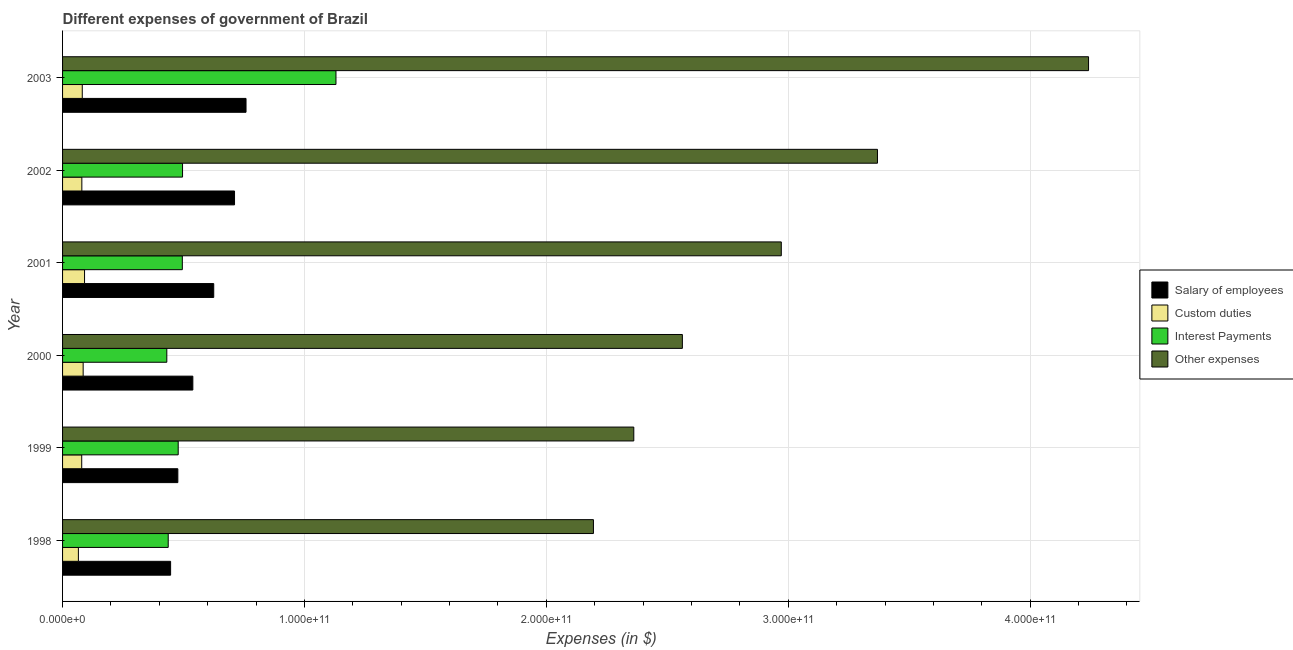Are the number of bars per tick equal to the number of legend labels?
Make the answer very short. Yes. Are the number of bars on each tick of the Y-axis equal?
Make the answer very short. Yes. What is the label of the 4th group of bars from the top?
Your answer should be compact. 2000. What is the amount spent on custom duties in 2001?
Your answer should be very brief. 9.09e+09. Across all years, what is the maximum amount spent on other expenses?
Provide a short and direct response. 4.24e+11. Across all years, what is the minimum amount spent on other expenses?
Offer a terse response. 2.19e+11. In which year was the amount spent on interest payments maximum?
Give a very brief answer. 2003. What is the total amount spent on interest payments in the graph?
Your response must be concise. 3.47e+11. What is the difference between the amount spent on interest payments in 2000 and that in 2003?
Ensure brevity in your answer.  -6.99e+1. What is the difference between the amount spent on custom duties in 1999 and the amount spent on interest payments in 1998?
Give a very brief answer. -3.58e+1. What is the average amount spent on custom duties per year?
Your answer should be very brief. 8.03e+09. In the year 1999, what is the difference between the amount spent on custom duties and amount spent on interest payments?
Make the answer very short. -3.99e+1. What is the ratio of the amount spent on salary of employees in 2001 to that in 2002?
Provide a short and direct response. 0.88. Is the difference between the amount spent on interest payments in 1999 and 2003 greater than the difference between the amount spent on salary of employees in 1999 and 2003?
Your answer should be very brief. No. What is the difference between the highest and the second highest amount spent on other expenses?
Offer a very short reply. 8.73e+1. What is the difference between the highest and the lowest amount spent on other expenses?
Offer a terse response. 2.05e+11. In how many years, is the amount spent on custom duties greater than the average amount spent on custom duties taken over all years?
Your answer should be very brief. 3. Is it the case that in every year, the sum of the amount spent on interest payments and amount spent on salary of employees is greater than the sum of amount spent on custom duties and amount spent on other expenses?
Offer a very short reply. No. What does the 2nd bar from the top in 2003 represents?
Give a very brief answer. Interest Payments. What does the 4th bar from the bottom in 2001 represents?
Ensure brevity in your answer.  Other expenses. Is it the case that in every year, the sum of the amount spent on salary of employees and amount spent on custom duties is greater than the amount spent on interest payments?
Offer a very short reply. No. How many bars are there?
Your answer should be compact. 24. Are all the bars in the graph horizontal?
Make the answer very short. Yes. What is the difference between two consecutive major ticks on the X-axis?
Ensure brevity in your answer.  1.00e+11. Are the values on the major ticks of X-axis written in scientific E-notation?
Ensure brevity in your answer.  Yes. Does the graph contain grids?
Offer a terse response. Yes. What is the title of the graph?
Give a very brief answer. Different expenses of government of Brazil. What is the label or title of the X-axis?
Your response must be concise. Expenses (in $). What is the label or title of the Y-axis?
Ensure brevity in your answer.  Year. What is the Expenses (in $) in Salary of employees in 1998?
Your answer should be very brief. 4.47e+1. What is the Expenses (in $) in Custom duties in 1998?
Keep it short and to the point. 6.54e+09. What is the Expenses (in $) of Interest Payments in 1998?
Offer a very short reply. 4.37e+1. What is the Expenses (in $) in Other expenses in 1998?
Provide a succinct answer. 2.19e+11. What is the Expenses (in $) of Salary of employees in 1999?
Provide a succinct answer. 4.77e+1. What is the Expenses (in $) in Custom duties in 1999?
Ensure brevity in your answer.  7.92e+09. What is the Expenses (in $) of Interest Payments in 1999?
Ensure brevity in your answer.  4.78e+1. What is the Expenses (in $) of Other expenses in 1999?
Offer a very short reply. 2.36e+11. What is the Expenses (in $) in Salary of employees in 2000?
Provide a short and direct response. 5.39e+1. What is the Expenses (in $) in Custom duties in 2000?
Provide a succinct answer. 8.51e+09. What is the Expenses (in $) in Interest Payments in 2000?
Offer a terse response. 4.31e+1. What is the Expenses (in $) in Other expenses in 2000?
Keep it short and to the point. 2.56e+11. What is the Expenses (in $) in Salary of employees in 2001?
Make the answer very short. 6.25e+1. What is the Expenses (in $) of Custom duties in 2001?
Provide a short and direct response. 9.09e+09. What is the Expenses (in $) in Interest Payments in 2001?
Offer a very short reply. 4.95e+1. What is the Expenses (in $) in Other expenses in 2001?
Offer a terse response. 2.97e+11. What is the Expenses (in $) of Salary of employees in 2002?
Your answer should be compact. 7.11e+1. What is the Expenses (in $) in Custom duties in 2002?
Make the answer very short. 7.97e+09. What is the Expenses (in $) in Interest Payments in 2002?
Make the answer very short. 4.96e+1. What is the Expenses (in $) of Other expenses in 2002?
Your response must be concise. 3.37e+11. What is the Expenses (in $) in Salary of employees in 2003?
Provide a succinct answer. 7.58e+1. What is the Expenses (in $) in Custom duties in 2003?
Your answer should be very brief. 8.14e+09. What is the Expenses (in $) in Interest Payments in 2003?
Offer a very short reply. 1.13e+11. What is the Expenses (in $) of Other expenses in 2003?
Your response must be concise. 4.24e+11. Across all years, what is the maximum Expenses (in $) of Salary of employees?
Provide a short and direct response. 7.58e+1. Across all years, what is the maximum Expenses (in $) of Custom duties?
Make the answer very short. 9.09e+09. Across all years, what is the maximum Expenses (in $) of Interest Payments?
Ensure brevity in your answer.  1.13e+11. Across all years, what is the maximum Expenses (in $) of Other expenses?
Offer a very short reply. 4.24e+11. Across all years, what is the minimum Expenses (in $) in Salary of employees?
Make the answer very short. 4.47e+1. Across all years, what is the minimum Expenses (in $) in Custom duties?
Offer a very short reply. 6.54e+09. Across all years, what is the minimum Expenses (in $) of Interest Payments?
Ensure brevity in your answer.  4.31e+1. Across all years, what is the minimum Expenses (in $) in Other expenses?
Offer a very short reply. 2.19e+11. What is the total Expenses (in $) in Salary of employees in the graph?
Your response must be concise. 3.56e+11. What is the total Expenses (in $) in Custom duties in the graph?
Provide a succinct answer. 4.82e+1. What is the total Expenses (in $) of Interest Payments in the graph?
Provide a short and direct response. 3.47e+11. What is the total Expenses (in $) of Other expenses in the graph?
Your answer should be compact. 1.77e+12. What is the difference between the Expenses (in $) in Salary of employees in 1998 and that in 1999?
Offer a very short reply. -2.99e+09. What is the difference between the Expenses (in $) of Custom duties in 1998 and that in 1999?
Offer a terse response. -1.37e+09. What is the difference between the Expenses (in $) of Interest Payments in 1998 and that in 1999?
Ensure brevity in your answer.  -4.13e+09. What is the difference between the Expenses (in $) in Other expenses in 1998 and that in 1999?
Keep it short and to the point. -1.67e+1. What is the difference between the Expenses (in $) in Salary of employees in 1998 and that in 2000?
Make the answer very short. -9.19e+09. What is the difference between the Expenses (in $) of Custom duties in 1998 and that in 2000?
Your answer should be compact. -1.97e+09. What is the difference between the Expenses (in $) of Interest Payments in 1998 and that in 2000?
Your answer should be very brief. 5.82e+08. What is the difference between the Expenses (in $) of Other expenses in 1998 and that in 2000?
Ensure brevity in your answer.  -3.68e+1. What is the difference between the Expenses (in $) in Salary of employees in 1998 and that in 2001?
Provide a succinct answer. -1.78e+1. What is the difference between the Expenses (in $) in Custom duties in 1998 and that in 2001?
Keep it short and to the point. -2.54e+09. What is the difference between the Expenses (in $) of Interest Payments in 1998 and that in 2001?
Offer a terse response. -5.83e+09. What is the difference between the Expenses (in $) of Other expenses in 1998 and that in 2001?
Your answer should be compact. -7.77e+1. What is the difference between the Expenses (in $) in Salary of employees in 1998 and that in 2002?
Give a very brief answer. -2.64e+1. What is the difference between the Expenses (in $) of Custom duties in 1998 and that in 2002?
Give a very brief answer. -1.43e+09. What is the difference between the Expenses (in $) of Interest Payments in 1998 and that in 2002?
Offer a terse response. -5.92e+09. What is the difference between the Expenses (in $) of Other expenses in 1998 and that in 2002?
Make the answer very short. -1.17e+11. What is the difference between the Expenses (in $) of Salary of employees in 1998 and that in 2003?
Offer a very short reply. -3.12e+1. What is the difference between the Expenses (in $) in Custom duties in 1998 and that in 2003?
Ensure brevity in your answer.  -1.60e+09. What is the difference between the Expenses (in $) in Interest Payments in 1998 and that in 2003?
Offer a very short reply. -6.93e+1. What is the difference between the Expenses (in $) of Other expenses in 1998 and that in 2003?
Your response must be concise. -2.05e+11. What is the difference between the Expenses (in $) in Salary of employees in 1999 and that in 2000?
Provide a short and direct response. -6.20e+09. What is the difference between the Expenses (in $) in Custom duties in 1999 and that in 2000?
Give a very brief answer. -5.94e+08. What is the difference between the Expenses (in $) of Interest Payments in 1999 and that in 2000?
Keep it short and to the point. 4.71e+09. What is the difference between the Expenses (in $) in Other expenses in 1999 and that in 2000?
Ensure brevity in your answer.  -2.01e+1. What is the difference between the Expenses (in $) of Salary of employees in 1999 and that in 2001?
Provide a short and direct response. -1.48e+1. What is the difference between the Expenses (in $) of Custom duties in 1999 and that in 2001?
Make the answer very short. -1.17e+09. What is the difference between the Expenses (in $) of Interest Payments in 1999 and that in 2001?
Your answer should be very brief. -1.71e+09. What is the difference between the Expenses (in $) in Other expenses in 1999 and that in 2001?
Offer a very short reply. -6.10e+1. What is the difference between the Expenses (in $) in Salary of employees in 1999 and that in 2002?
Your answer should be compact. -2.34e+1. What is the difference between the Expenses (in $) in Custom duties in 1999 and that in 2002?
Offer a very short reply. -5.38e+07. What is the difference between the Expenses (in $) in Interest Payments in 1999 and that in 2002?
Make the answer very short. -1.80e+09. What is the difference between the Expenses (in $) of Other expenses in 1999 and that in 2002?
Make the answer very short. -1.01e+11. What is the difference between the Expenses (in $) in Salary of employees in 1999 and that in 2003?
Your answer should be very brief. -2.82e+1. What is the difference between the Expenses (in $) of Custom duties in 1999 and that in 2003?
Your response must be concise. -2.26e+08. What is the difference between the Expenses (in $) of Interest Payments in 1999 and that in 2003?
Your answer should be very brief. -6.52e+1. What is the difference between the Expenses (in $) in Other expenses in 1999 and that in 2003?
Provide a succinct answer. -1.88e+11. What is the difference between the Expenses (in $) of Salary of employees in 2000 and that in 2001?
Provide a succinct answer. -8.64e+09. What is the difference between the Expenses (in $) in Custom duties in 2000 and that in 2001?
Keep it short and to the point. -5.77e+08. What is the difference between the Expenses (in $) in Interest Payments in 2000 and that in 2001?
Give a very brief answer. -6.41e+09. What is the difference between the Expenses (in $) of Other expenses in 2000 and that in 2001?
Your answer should be compact. -4.09e+1. What is the difference between the Expenses (in $) in Salary of employees in 2000 and that in 2002?
Make the answer very short. -1.72e+1. What is the difference between the Expenses (in $) in Custom duties in 2000 and that in 2002?
Provide a short and direct response. 5.40e+08. What is the difference between the Expenses (in $) of Interest Payments in 2000 and that in 2002?
Your answer should be compact. -6.51e+09. What is the difference between the Expenses (in $) in Other expenses in 2000 and that in 2002?
Offer a terse response. -8.06e+1. What is the difference between the Expenses (in $) of Salary of employees in 2000 and that in 2003?
Your answer should be compact. -2.20e+1. What is the difference between the Expenses (in $) in Custom duties in 2000 and that in 2003?
Keep it short and to the point. 3.68e+08. What is the difference between the Expenses (in $) of Interest Payments in 2000 and that in 2003?
Provide a succinct answer. -6.99e+1. What is the difference between the Expenses (in $) of Other expenses in 2000 and that in 2003?
Provide a short and direct response. -1.68e+11. What is the difference between the Expenses (in $) of Salary of employees in 2001 and that in 2002?
Offer a terse response. -8.60e+09. What is the difference between the Expenses (in $) of Custom duties in 2001 and that in 2002?
Provide a succinct answer. 1.12e+09. What is the difference between the Expenses (in $) of Interest Payments in 2001 and that in 2002?
Give a very brief answer. -9.06e+07. What is the difference between the Expenses (in $) of Other expenses in 2001 and that in 2002?
Give a very brief answer. -3.98e+1. What is the difference between the Expenses (in $) of Salary of employees in 2001 and that in 2003?
Offer a terse response. -1.33e+1. What is the difference between the Expenses (in $) in Custom duties in 2001 and that in 2003?
Provide a short and direct response. 9.45e+08. What is the difference between the Expenses (in $) of Interest Payments in 2001 and that in 2003?
Keep it short and to the point. -6.35e+1. What is the difference between the Expenses (in $) of Other expenses in 2001 and that in 2003?
Your answer should be compact. -1.27e+11. What is the difference between the Expenses (in $) in Salary of employees in 2002 and that in 2003?
Keep it short and to the point. -4.75e+09. What is the difference between the Expenses (in $) of Custom duties in 2002 and that in 2003?
Ensure brevity in your answer.  -1.72e+08. What is the difference between the Expenses (in $) of Interest Payments in 2002 and that in 2003?
Your answer should be compact. -6.34e+1. What is the difference between the Expenses (in $) of Other expenses in 2002 and that in 2003?
Provide a succinct answer. -8.73e+1. What is the difference between the Expenses (in $) in Salary of employees in 1998 and the Expenses (in $) in Custom duties in 1999?
Ensure brevity in your answer.  3.67e+1. What is the difference between the Expenses (in $) of Salary of employees in 1998 and the Expenses (in $) of Interest Payments in 1999?
Make the answer very short. -3.14e+09. What is the difference between the Expenses (in $) of Salary of employees in 1998 and the Expenses (in $) of Other expenses in 1999?
Ensure brevity in your answer.  -1.91e+11. What is the difference between the Expenses (in $) in Custom duties in 1998 and the Expenses (in $) in Interest Payments in 1999?
Ensure brevity in your answer.  -4.13e+1. What is the difference between the Expenses (in $) of Custom duties in 1998 and the Expenses (in $) of Other expenses in 1999?
Give a very brief answer. -2.30e+11. What is the difference between the Expenses (in $) in Interest Payments in 1998 and the Expenses (in $) in Other expenses in 1999?
Make the answer very short. -1.92e+11. What is the difference between the Expenses (in $) in Salary of employees in 1998 and the Expenses (in $) in Custom duties in 2000?
Make the answer very short. 3.62e+1. What is the difference between the Expenses (in $) of Salary of employees in 1998 and the Expenses (in $) of Interest Payments in 2000?
Ensure brevity in your answer.  1.57e+09. What is the difference between the Expenses (in $) in Salary of employees in 1998 and the Expenses (in $) in Other expenses in 2000?
Your answer should be very brief. -2.12e+11. What is the difference between the Expenses (in $) of Custom duties in 1998 and the Expenses (in $) of Interest Payments in 2000?
Offer a very short reply. -3.65e+1. What is the difference between the Expenses (in $) of Custom duties in 1998 and the Expenses (in $) of Other expenses in 2000?
Offer a very short reply. -2.50e+11. What is the difference between the Expenses (in $) of Interest Payments in 1998 and the Expenses (in $) of Other expenses in 2000?
Your answer should be very brief. -2.13e+11. What is the difference between the Expenses (in $) in Salary of employees in 1998 and the Expenses (in $) in Custom duties in 2001?
Make the answer very short. 3.56e+1. What is the difference between the Expenses (in $) of Salary of employees in 1998 and the Expenses (in $) of Interest Payments in 2001?
Your answer should be compact. -4.84e+09. What is the difference between the Expenses (in $) in Salary of employees in 1998 and the Expenses (in $) in Other expenses in 2001?
Your answer should be very brief. -2.52e+11. What is the difference between the Expenses (in $) in Custom duties in 1998 and the Expenses (in $) in Interest Payments in 2001?
Offer a very short reply. -4.30e+1. What is the difference between the Expenses (in $) in Custom duties in 1998 and the Expenses (in $) in Other expenses in 2001?
Offer a very short reply. -2.91e+11. What is the difference between the Expenses (in $) in Interest Payments in 1998 and the Expenses (in $) in Other expenses in 2001?
Offer a terse response. -2.53e+11. What is the difference between the Expenses (in $) of Salary of employees in 1998 and the Expenses (in $) of Custom duties in 2002?
Your answer should be very brief. 3.67e+1. What is the difference between the Expenses (in $) in Salary of employees in 1998 and the Expenses (in $) in Interest Payments in 2002?
Offer a very short reply. -4.93e+09. What is the difference between the Expenses (in $) in Salary of employees in 1998 and the Expenses (in $) in Other expenses in 2002?
Ensure brevity in your answer.  -2.92e+11. What is the difference between the Expenses (in $) of Custom duties in 1998 and the Expenses (in $) of Interest Payments in 2002?
Your response must be concise. -4.31e+1. What is the difference between the Expenses (in $) of Custom duties in 1998 and the Expenses (in $) of Other expenses in 2002?
Offer a terse response. -3.30e+11. What is the difference between the Expenses (in $) of Interest Payments in 1998 and the Expenses (in $) of Other expenses in 2002?
Offer a terse response. -2.93e+11. What is the difference between the Expenses (in $) of Salary of employees in 1998 and the Expenses (in $) of Custom duties in 2003?
Offer a terse response. 3.65e+1. What is the difference between the Expenses (in $) of Salary of employees in 1998 and the Expenses (in $) of Interest Payments in 2003?
Your answer should be very brief. -6.84e+1. What is the difference between the Expenses (in $) of Salary of employees in 1998 and the Expenses (in $) of Other expenses in 2003?
Your response must be concise. -3.79e+11. What is the difference between the Expenses (in $) of Custom duties in 1998 and the Expenses (in $) of Interest Payments in 2003?
Make the answer very short. -1.06e+11. What is the difference between the Expenses (in $) of Custom duties in 1998 and the Expenses (in $) of Other expenses in 2003?
Your answer should be compact. -4.18e+11. What is the difference between the Expenses (in $) in Interest Payments in 1998 and the Expenses (in $) in Other expenses in 2003?
Offer a terse response. -3.80e+11. What is the difference between the Expenses (in $) of Salary of employees in 1999 and the Expenses (in $) of Custom duties in 2000?
Make the answer very short. 3.91e+1. What is the difference between the Expenses (in $) of Salary of employees in 1999 and the Expenses (in $) of Interest Payments in 2000?
Offer a terse response. 4.56e+09. What is the difference between the Expenses (in $) in Salary of employees in 1999 and the Expenses (in $) in Other expenses in 2000?
Give a very brief answer. -2.09e+11. What is the difference between the Expenses (in $) in Custom duties in 1999 and the Expenses (in $) in Interest Payments in 2000?
Your answer should be very brief. -3.52e+1. What is the difference between the Expenses (in $) in Custom duties in 1999 and the Expenses (in $) in Other expenses in 2000?
Make the answer very short. -2.48e+11. What is the difference between the Expenses (in $) of Interest Payments in 1999 and the Expenses (in $) of Other expenses in 2000?
Ensure brevity in your answer.  -2.08e+11. What is the difference between the Expenses (in $) in Salary of employees in 1999 and the Expenses (in $) in Custom duties in 2001?
Your answer should be compact. 3.86e+1. What is the difference between the Expenses (in $) of Salary of employees in 1999 and the Expenses (in $) of Interest Payments in 2001?
Offer a very short reply. -1.85e+09. What is the difference between the Expenses (in $) in Salary of employees in 1999 and the Expenses (in $) in Other expenses in 2001?
Give a very brief answer. -2.49e+11. What is the difference between the Expenses (in $) of Custom duties in 1999 and the Expenses (in $) of Interest Payments in 2001?
Offer a very short reply. -4.16e+1. What is the difference between the Expenses (in $) in Custom duties in 1999 and the Expenses (in $) in Other expenses in 2001?
Give a very brief answer. -2.89e+11. What is the difference between the Expenses (in $) in Interest Payments in 1999 and the Expenses (in $) in Other expenses in 2001?
Provide a succinct answer. -2.49e+11. What is the difference between the Expenses (in $) in Salary of employees in 1999 and the Expenses (in $) in Custom duties in 2002?
Keep it short and to the point. 3.97e+1. What is the difference between the Expenses (in $) of Salary of employees in 1999 and the Expenses (in $) of Interest Payments in 2002?
Your response must be concise. -1.94e+09. What is the difference between the Expenses (in $) in Salary of employees in 1999 and the Expenses (in $) in Other expenses in 2002?
Your response must be concise. -2.89e+11. What is the difference between the Expenses (in $) in Custom duties in 1999 and the Expenses (in $) in Interest Payments in 2002?
Make the answer very short. -4.17e+1. What is the difference between the Expenses (in $) in Custom duties in 1999 and the Expenses (in $) in Other expenses in 2002?
Your answer should be very brief. -3.29e+11. What is the difference between the Expenses (in $) in Interest Payments in 1999 and the Expenses (in $) in Other expenses in 2002?
Your response must be concise. -2.89e+11. What is the difference between the Expenses (in $) in Salary of employees in 1999 and the Expenses (in $) in Custom duties in 2003?
Offer a terse response. 3.95e+1. What is the difference between the Expenses (in $) in Salary of employees in 1999 and the Expenses (in $) in Interest Payments in 2003?
Your answer should be compact. -6.54e+1. What is the difference between the Expenses (in $) of Salary of employees in 1999 and the Expenses (in $) of Other expenses in 2003?
Provide a succinct answer. -3.76e+11. What is the difference between the Expenses (in $) in Custom duties in 1999 and the Expenses (in $) in Interest Payments in 2003?
Offer a terse response. -1.05e+11. What is the difference between the Expenses (in $) in Custom duties in 1999 and the Expenses (in $) in Other expenses in 2003?
Your answer should be very brief. -4.16e+11. What is the difference between the Expenses (in $) of Interest Payments in 1999 and the Expenses (in $) of Other expenses in 2003?
Your response must be concise. -3.76e+11. What is the difference between the Expenses (in $) of Salary of employees in 2000 and the Expenses (in $) of Custom duties in 2001?
Keep it short and to the point. 4.48e+1. What is the difference between the Expenses (in $) of Salary of employees in 2000 and the Expenses (in $) of Interest Payments in 2001?
Your answer should be compact. 4.35e+09. What is the difference between the Expenses (in $) of Salary of employees in 2000 and the Expenses (in $) of Other expenses in 2001?
Keep it short and to the point. -2.43e+11. What is the difference between the Expenses (in $) of Custom duties in 2000 and the Expenses (in $) of Interest Payments in 2001?
Give a very brief answer. -4.10e+1. What is the difference between the Expenses (in $) in Custom duties in 2000 and the Expenses (in $) in Other expenses in 2001?
Your answer should be very brief. -2.89e+11. What is the difference between the Expenses (in $) in Interest Payments in 2000 and the Expenses (in $) in Other expenses in 2001?
Your answer should be very brief. -2.54e+11. What is the difference between the Expenses (in $) in Salary of employees in 2000 and the Expenses (in $) in Custom duties in 2002?
Your answer should be compact. 4.59e+1. What is the difference between the Expenses (in $) of Salary of employees in 2000 and the Expenses (in $) of Interest Payments in 2002?
Offer a terse response. 4.26e+09. What is the difference between the Expenses (in $) in Salary of employees in 2000 and the Expenses (in $) in Other expenses in 2002?
Your answer should be very brief. -2.83e+11. What is the difference between the Expenses (in $) in Custom duties in 2000 and the Expenses (in $) in Interest Payments in 2002?
Make the answer very short. -4.11e+1. What is the difference between the Expenses (in $) in Custom duties in 2000 and the Expenses (in $) in Other expenses in 2002?
Keep it short and to the point. -3.28e+11. What is the difference between the Expenses (in $) in Interest Payments in 2000 and the Expenses (in $) in Other expenses in 2002?
Your response must be concise. -2.94e+11. What is the difference between the Expenses (in $) of Salary of employees in 2000 and the Expenses (in $) of Custom duties in 2003?
Offer a terse response. 4.57e+1. What is the difference between the Expenses (in $) of Salary of employees in 2000 and the Expenses (in $) of Interest Payments in 2003?
Give a very brief answer. -5.92e+1. What is the difference between the Expenses (in $) in Salary of employees in 2000 and the Expenses (in $) in Other expenses in 2003?
Keep it short and to the point. -3.70e+11. What is the difference between the Expenses (in $) in Custom duties in 2000 and the Expenses (in $) in Interest Payments in 2003?
Keep it short and to the point. -1.05e+11. What is the difference between the Expenses (in $) of Custom duties in 2000 and the Expenses (in $) of Other expenses in 2003?
Offer a very short reply. -4.16e+11. What is the difference between the Expenses (in $) in Interest Payments in 2000 and the Expenses (in $) in Other expenses in 2003?
Ensure brevity in your answer.  -3.81e+11. What is the difference between the Expenses (in $) of Salary of employees in 2001 and the Expenses (in $) of Custom duties in 2002?
Provide a succinct answer. 5.45e+1. What is the difference between the Expenses (in $) of Salary of employees in 2001 and the Expenses (in $) of Interest Payments in 2002?
Offer a very short reply. 1.29e+1. What is the difference between the Expenses (in $) of Salary of employees in 2001 and the Expenses (in $) of Other expenses in 2002?
Offer a terse response. -2.74e+11. What is the difference between the Expenses (in $) of Custom duties in 2001 and the Expenses (in $) of Interest Payments in 2002?
Provide a short and direct response. -4.05e+1. What is the difference between the Expenses (in $) in Custom duties in 2001 and the Expenses (in $) in Other expenses in 2002?
Offer a very short reply. -3.28e+11. What is the difference between the Expenses (in $) in Interest Payments in 2001 and the Expenses (in $) in Other expenses in 2002?
Provide a succinct answer. -2.87e+11. What is the difference between the Expenses (in $) in Salary of employees in 2001 and the Expenses (in $) in Custom duties in 2003?
Provide a succinct answer. 5.44e+1. What is the difference between the Expenses (in $) of Salary of employees in 2001 and the Expenses (in $) of Interest Payments in 2003?
Your response must be concise. -5.05e+1. What is the difference between the Expenses (in $) in Salary of employees in 2001 and the Expenses (in $) in Other expenses in 2003?
Provide a short and direct response. -3.62e+11. What is the difference between the Expenses (in $) in Custom duties in 2001 and the Expenses (in $) in Interest Payments in 2003?
Ensure brevity in your answer.  -1.04e+11. What is the difference between the Expenses (in $) of Custom duties in 2001 and the Expenses (in $) of Other expenses in 2003?
Ensure brevity in your answer.  -4.15e+11. What is the difference between the Expenses (in $) of Interest Payments in 2001 and the Expenses (in $) of Other expenses in 2003?
Your answer should be compact. -3.75e+11. What is the difference between the Expenses (in $) of Salary of employees in 2002 and the Expenses (in $) of Custom duties in 2003?
Keep it short and to the point. 6.29e+1. What is the difference between the Expenses (in $) of Salary of employees in 2002 and the Expenses (in $) of Interest Payments in 2003?
Make the answer very short. -4.19e+1. What is the difference between the Expenses (in $) in Salary of employees in 2002 and the Expenses (in $) in Other expenses in 2003?
Ensure brevity in your answer.  -3.53e+11. What is the difference between the Expenses (in $) in Custom duties in 2002 and the Expenses (in $) in Interest Payments in 2003?
Your response must be concise. -1.05e+11. What is the difference between the Expenses (in $) of Custom duties in 2002 and the Expenses (in $) of Other expenses in 2003?
Give a very brief answer. -4.16e+11. What is the difference between the Expenses (in $) of Interest Payments in 2002 and the Expenses (in $) of Other expenses in 2003?
Make the answer very short. -3.75e+11. What is the average Expenses (in $) of Salary of employees per year?
Provide a succinct answer. 5.93e+1. What is the average Expenses (in $) of Custom duties per year?
Offer a very short reply. 8.03e+09. What is the average Expenses (in $) of Interest Payments per year?
Keep it short and to the point. 5.78e+1. What is the average Expenses (in $) of Other expenses per year?
Offer a terse response. 2.95e+11. In the year 1998, what is the difference between the Expenses (in $) of Salary of employees and Expenses (in $) of Custom duties?
Your answer should be compact. 3.81e+1. In the year 1998, what is the difference between the Expenses (in $) of Salary of employees and Expenses (in $) of Interest Payments?
Offer a very short reply. 9.90e+08. In the year 1998, what is the difference between the Expenses (in $) in Salary of employees and Expenses (in $) in Other expenses?
Your answer should be compact. -1.75e+11. In the year 1998, what is the difference between the Expenses (in $) in Custom duties and Expenses (in $) in Interest Payments?
Give a very brief answer. -3.71e+1. In the year 1998, what is the difference between the Expenses (in $) in Custom duties and Expenses (in $) in Other expenses?
Your answer should be very brief. -2.13e+11. In the year 1998, what is the difference between the Expenses (in $) of Interest Payments and Expenses (in $) of Other expenses?
Your answer should be compact. -1.76e+11. In the year 1999, what is the difference between the Expenses (in $) of Salary of employees and Expenses (in $) of Custom duties?
Provide a succinct answer. 3.97e+1. In the year 1999, what is the difference between the Expenses (in $) in Salary of employees and Expenses (in $) in Interest Payments?
Keep it short and to the point. -1.48e+08. In the year 1999, what is the difference between the Expenses (in $) of Salary of employees and Expenses (in $) of Other expenses?
Your answer should be very brief. -1.88e+11. In the year 1999, what is the difference between the Expenses (in $) in Custom duties and Expenses (in $) in Interest Payments?
Offer a terse response. -3.99e+1. In the year 1999, what is the difference between the Expenses (in $) in Custom duties and Expenses (in $) in Other expenses?
Give a very brief answer. -2.28e+11. In the year 1999, what is the difference between the Expenses (in $) of Interest Payments and Expenses (in $) of Other expenses?
Ensure brevity in your answer.  -1.88e+11. In the year 2000, what is the difference between the Expenses (in $) of Salary of employees and Expenses (in $) of Custom duties?
Provide a short and direct response. 4.53e+1. In the year 2000, what is the difference between the Expenses (in $) in Salary of employees and Expenses (in $) in Interest Payments?
Give a very brief answer. 1.08e+1. In the year 2000, what is the difference between the Expenses (in $) in Salary of employees and Expenses (in $) in Other expenses?
Keep it short and to the point. -2.02e+11. In the year 2000, what is the difference between the Expenses (in $) in Custom duties and Expenses (in $) in Interest Payments?
Your answer should be compact. -3.46e+1. In the year 2000, what is the difference between the Expenses (in $) of Custom duties and Expenses (in $) of Other expenses?
Your answer should be very brief. -2.48e+11. In the year 2000, what is the difference between the Expenses (in $) of Interest Payments and Expenses (in $) of Other expenses?
Offer a very short reply. -2.13e+11. In the year 2001, what is the difference between the Expenses (in $) in Salary of employees and Expenses (in $) in Custom duties?
Ensure brevity in your answer.  5.34e+1. In the year 2001, what is the difference between the Expenses (in $) in Salary of employees and Expenses (in $) in Interest Payments?
Offer a very short reply. 1.30e+1. In the year 2001, what is the difference between the Expenses (in $) of Salary of employees and Expenses (in $) of Other expenses?
Provide a short and direct response. -2.35e+11. In the year 2001, what is the difference between the Expenses (in $) of Custom duties and Expenses (in $) of Interest Payments?
Keep it short and to the point. -4.04e+1. In the year 2001, what is the difference between the Expenses (in $) in Custom duties and Expenses (in $) in Other expenses?
Ensure brevity in your answer.  -2.88e+11. In the year 2001, what is the difference between the Expenses (in $) of Interest Payments and Expenses (in $) of Other expenses?
Your answer should be compact. -2.48e+11. In the year 2002, what is the difference between the Expenses (in $) of Salary of employees and Expenses (in $) of Custom duties?
Keep it short and to the point. 6.31e+1. In the year 2002, what is the difference between the Expenses (in $) of Salary of employees and Expenses (in $) of Interest Payments?
Your response must be concise. 2.15e+1. In the year 2002, what is the difference between the Expenses (in $) in Salary of employees and Expenses (in $) in Other expenses?
Offer a very short reply. -2.66e+11. In the year 2002, what is the difference between the Expenses (in $) in Custom duties and Expenses (in $) in Interest Payments?
Offer a very short reply. -4.16e+1. In the year 2002, what is the difference between the Expenses (in $) of Custom duties and Expenses (in $) of Other expenses?
Offer a terse response. -3.29e+11. In the year 2002, what is the difference between the Expenses (in $) in Interest Payments and Expenses (in $) in Other expenses?
Ensure brevity in your answer.  -2.87e+11. In the year 2003, what is the difference between the Expenses (in $) in Salary of employees and Expenses (in $) in Custom duties?
Ensure brevity in your answer.  6.77e+1. In the year 2003, what is the difference between the Expenses (in $) of Salary of employees and Expenses (in $) of Interest Payments?
Your response must be concise. -3.72e+1. In the year 2003, what is the difference between the Expenses (in $) of Salary of employees and Expenses (in $) of Other expenses?
Give a very brief answer. -3.48e+11. In the year 2003, what is the difference between the Expenses (in $) of Custom duties and Expenses (in $) of Interest Payments?
Your answer should be very brief. -1.05e+11. In the year 2003, what is the difference between the Expenses (in $) in Custom duties and Expenses (in $) in Other expenses?
Provide a short and direct response. -4.16e+11. In the year 2003, what is the difference between the Expenses (in $) of Interest Payments and Expenses (in $) of Other expenses?
Your answer should be very brief. -3.11e+11. What is the ratio of the Expenses (in $) of Salary of employees in 1998 to that in 1999?
Keep it short and to the point. 0.94. What is the ratio of the Expenses (in $) of Custom duties in 1998 to that in 1999?
Offer a terse response. 0.83. What is the ratio of the Expenses (in $) in Interest Payments in 1998 to that in 1999?
Offer a very short reply. 0.91. What is the ratio of the Expenses (in $) of Other expenses in 1998 to that in 1999?
Give a very brief answer. 0.93. What is the ratio of the Expenses (in $) in Salary of employees in 1998 to that in 2000?
Give a very brief answer. 0.83. What is the ratio of the Expenses (in $) of Custom duties in 1998 to that in 2000?
Provide a short and direct response. 0.77. What is the ratio of the Expenses (in $) in Interest Payments in 1998 to that in 2000?
Ensure brevity in your answer.  1.01. What is the ratio of the Expenses (in $) of Other expenses in 1998 to that in 2000?
Ensure brevity in your answer.  0.86. What is the ratio of the Expenses (in $) of Salary of employees in 1998 to that in 2001?
Ensure brevity in your answer.  0.71. What is the ratio of the Expenses (in $) in Custom duties in 1998 to that in 2001?
Your answer should be very brief. 0.72. What is the ratio of the Expenses (in $) of Interest Payments in 1998 to that in 2001?
Provide a succinct answer. 0.88. What is the ratio of the Expenses (in $) of Other expenses in 1998 to that in 2001?
Give a very brief answer. 0.74. What is the ratio of the Expenses (in $) of Salary of employees in 1998 to that in 2002?
Keep it short and to the point. 0.63. What is the ratio of the Expenses (in $) in Custom duties in 1998 to that in 2002?
Your answer should be compact. 0.82. What is the ratio of the Expenses (in $) in Interest Payments in 1998 to that in 2002?
Give a very brief answer. 0.88. What is the ratio of the Expenses (in $) of Other expenses in 1998 to that in 2002?
Your answer should be compact. 0.65. What is the ratio of the Expenses (in $) of Salary of employees in 1998 to that in 2003?
Provide a succinct answer. 0.59. What is the ratio of the Expenses (in $) of Custom duties in 1998 to that in 2003?
Make the answer very short. 0.8. What is the ratio of the Expenses (in $) of Interest Payments in 1998 to that in 2003?
Your response must be concise. 0.39. What is the ratio of the Expenses (in $) of Other expenses in 1998 to that in 2003?
Ensure brevity in your answer.  0.52. What is the ratio of the Expenses (in $) of Salary of employees in 1999 to that in 2000?
Your answer should be very brief. 0.88. What is the ratio of the Expenses (in $) in Custom duties in 1999 to that in 2000?
Ensure brevity in your answer.  0.93. What is the ratio of the Expenses (in $) of Interest Payments in 1999 to that in 2000?
Your answer should be compact. 1.11. What is the ratio of the Expenses (in $) of Other expenses in 1999 to that in 2000?
Your answer should be compact. 0.92. What is the ratio of the Expenses (in $) of Salary of employees in 1999 to that in 2001?
Give a very brief answer. 0.76. What is the ratio of the Expenses (in $) of Custom duties in 1999 to that in 2001?
Your answer should be very brief. 0.87. What is the ratio of the Expenses (in $) of Interest Payments in 1999 to that in 2001?
Make the answer very short. 0.97. What is the ratio of the Expenses (in $) in Other expenses in 1999 to that in 2001?
Give a very brief answer. 0.79. What is the ratio of the Expenses (in $) in Salary of employees in 1999 to that in 2002?
Your answer should be compact. 0.67. What is the ratio of the Expenses (in $) of Custom duties in 1999 to that in 2002?
Provide a succinct answer. 0.99. What is the ratio of the Expenses (in $) in Interest Payments in 1999 to that in 2002?
Keep it short and to the point. 0.96. What is the ratio of the Expenses (in $) in Other expenses in 1999 to that in 2002?
Ensure brevity in your answer.  0.7. What is the ratio of the Expenses (in $) of Salary of employees in 1999 to that in 2003?
Provide a succinct answer. 0.63. What is the ratio of the Expenses (in $) in Custom duties in 1999 to that in 2003?
Offer a very short reply. 0.97. What is the ratio of the Expenses (in $) of Interest Payments in 1999 to that in 2003?
Offer a terse response. 0.42. What is the ratio of the Expenses (in $) in Other expenses in 1999 to that in 2003?
Provide a short and direct response. 0.56. What is the ratio of the Expenses (in $) in Salary of employees in 2000 to that in 2001?
Your answer should be very brief. 0.86. What is the ratio of the Expenses (in $) in Custom duties in 2000 to that in 2001?
Give a very brief answer. 0.94. What is the ratio of the Expenses (in $) of Interest Payments in 2000 to that in 2001?
Give a very brief answer. 0.87. What is the ratio of the Expenses (in $) in Other expenses in 2000 to that in 2001?
Give a very brief answer. 0.86. What is the ratio of the Expenses (in $) of Salary of employees in 2000 to that in 2002?
Ensure brevity in your answer.  0.76. What is the ratio of the Expenses (in $) in Custom duties in 2000 to that in 2002?
Your response must be concise. 1.07. What is the ratio of the Expenses (in $) of Interest Payments in 2000 to that in 2002?
Ensure brevity in your answer.  0.87. What is the ratio of the Expenses (in $) in Other expenses in 2000 to that in 2002?
Give a very brief answer. 0.76. What is the ratio of the Expenses (in $) of Salary of employees in 2000 to that in 2003?
Your response must be concise. 0.71. What is the ratio of the Expenses (in $) of Custom duties in 2000 to that in 2003?
Your response must be concise. 1.05. What is the ratio of the Expenses (in $) in Interest Payments in 2000 to that in 2003?
Your response must be concise. 0.38. What is the ratio of the Expenses (in $) in Other expenses in 2000 to that in 2003?
Offer a terse response. 0.6. What is the ratio of the Expenses (in $) of Salary of employees in 2001 to that in 2002?
Provide a short and direct response. 0.88. What is the ratio of the Expenses (in $) of Custom duties in 2001 to that in 2002?
Your answer should be compact. 1.14. What is the ratio of the Expenses (in $) in Interest Payments in 2001 to that in 2002?
Keep it short and to the point. 1. What is the ratio of the Expenses (in $) in Other expenses in 2001 to that in 2002?
Your response must be concise. 0.88. What is the ratio of the Expenses (in $) of Salary of employees in 2001 to that in 2003?
Make the answer very short. 0.82. What is the ratio of the Expenses (in $) of Custom duties in 2001 to that in 2003?
Your answer should be compact. 1.12. What is the ratio of the Expenses (in $) of Interest Payments in 2001 to that in 2003?
Keep it short and to the point. 0.44. What is the ratio of the Expenses (in $) of Other expenses in 2001 to that in 2003?
Ensure brevity in your answer.  0.7. What is the ratio of the Expenses (in $) of Salary of employees in 2002 to that in 2003?
Offer a terse response. 0.94. What is the ratio of the Expenses (in $) in Custom duties in 2002 to that in 2003?
Keep it short and to the point. 0.98. What is the ratio of the Expenses (in $) of Interest Payments in 2002 to that in 2003?
Your answer should be very brief. 0.44. What is the ratio of the Expenses (in $) of Other expenses in 2002 to that in 2003?
Your answer should be very brief. 0.79. What is the difference between the highest and the second highest Expenses (in $) in Salary of employees?
Offer a very short reply. 4.75e+09. What is the difference between the highest and the second highest Expenses (in $) in Custom duties?
Offer a terse response. 5.77e+08. What is the difference between the highest and the second highest Expenses (in $) in Interest Payments?
Provide a succinct answer. 6.34e+1. What is the difference between the highest and the second highest Expenses (in $) in Other expenses?
Provide a short and direct response. 8.73e+1. What is the difference between the highest and the lowest Expenses (in $) of Salary of employees?
Your answer should be compact. 3.12e+1. What is the difference between the highest and the lowest Expenses (in $) of Custom duties?
Offer a very short reply. 2.54e+09. What is the difference between the highest and the lowest Expenses (in $) in Interest Payments?
Provide a succinct answer. 6.99e+1. What is the difference between the highest and the lowest Expenses (in $) in Other expenses?
Keep it short and to the point. 2.05e+11. 